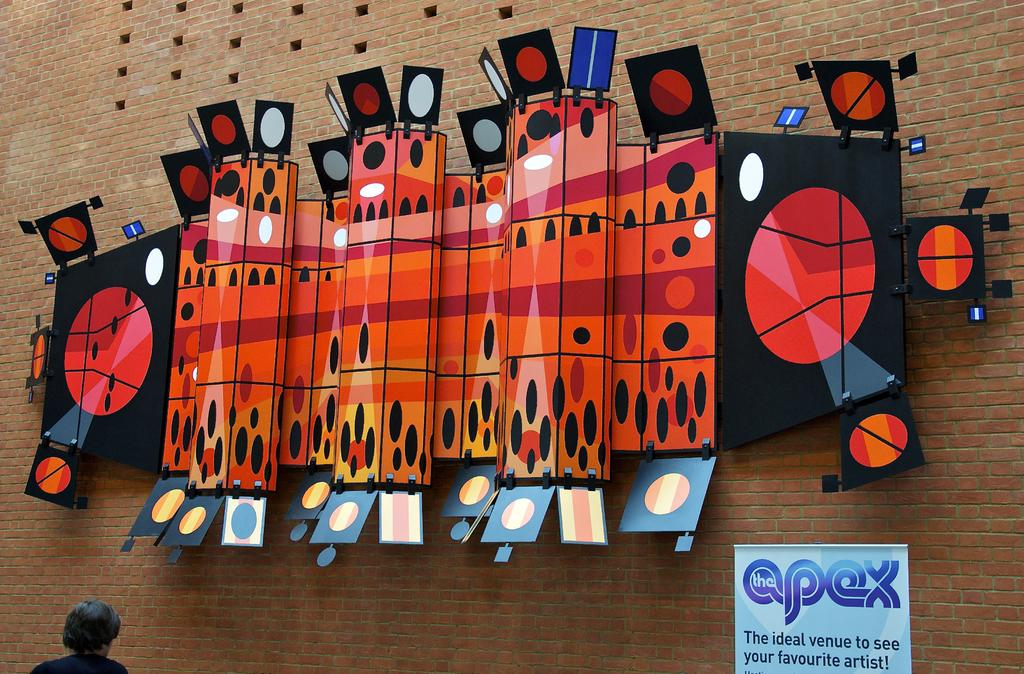What is the main subject of the image? There is a person in the image. What can be seen behind the person? There are boards on the wall in front of the person. Is there any text visible in the image? Yes, there is a banner with text in the image. How does the person in the image express disgust? There is no indication of the person expressing disgust in the image. What is the person doing with their chin in the image? The person's chin is not doing anything specific in the image. 